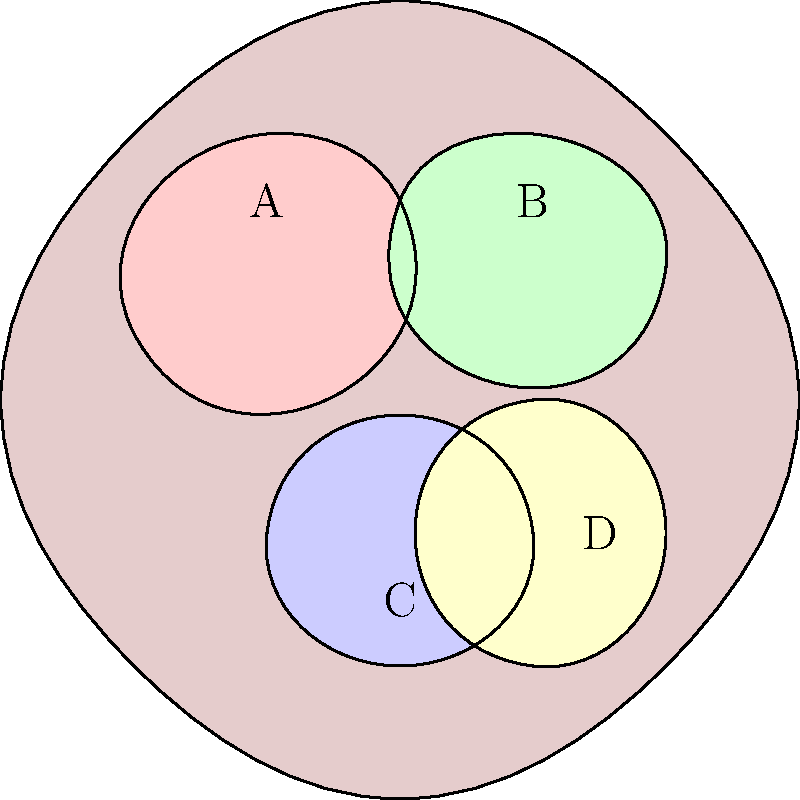In the labeled MRI scan of the brain above, which letter corresponds to the temporal lobe? To answer this question, let's go through the main lobes of the brain and their locations:

1. Frontal lobe: Located at the front of the brain, it's responsible for executive functions, motor control, and personality. In the image, this corresponds to region A.

2. Parietal lobe: Positioned behind the frontal lobe, it processes sensory information and is involved in spatial awareness. This is represented by region B in the image.

3. Temporal lobe: Found on the side of the brain, near the ears, it's involved in processing auditory information, memory, and language. In the image, this is region C.

4. Occipital lobe: Located at the back of the brain, it's primarily responsible for visual processing. This corresponds to region D in the image.

By examining the location and shape of each labeled region in the MRI scan, we can identify that the temporal lobe is represented by the letter C.
Answer: C 